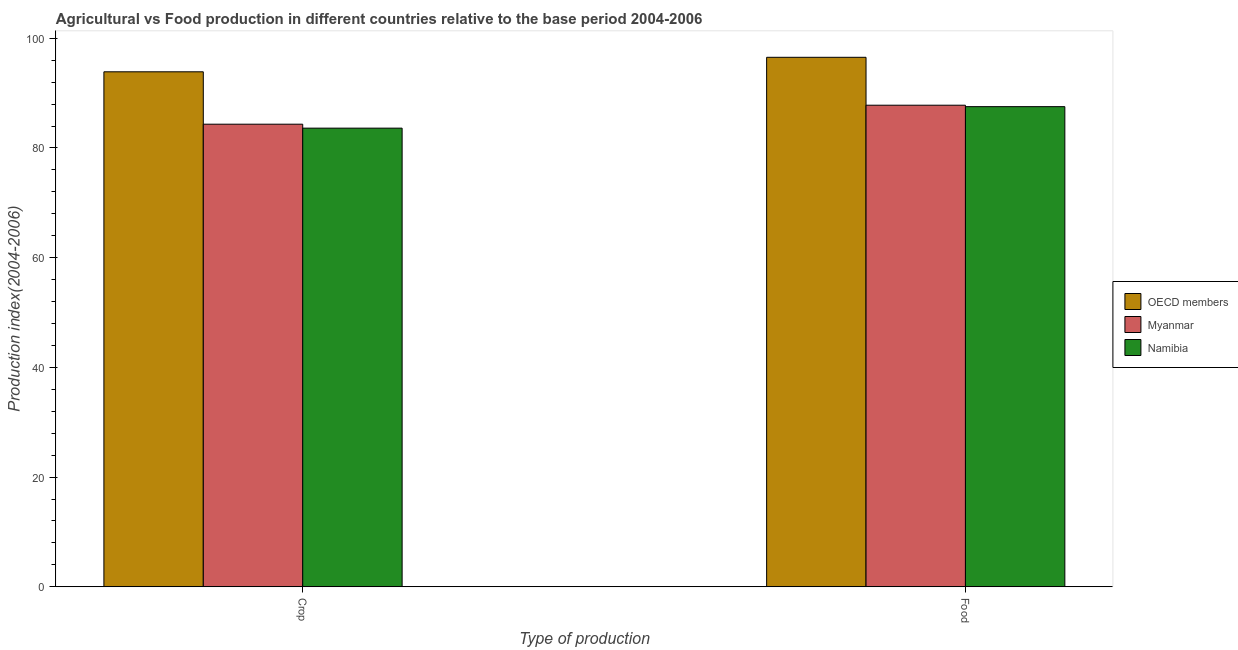How many groups of bars are there?
Offer a terse response. 2. Are the number of bars per tick equal to the number of legend labels?
Give a very brief answer. Yes. What is the label of the 2nd group of bars from the left?
Provide a succinct answer. Food. What is the crop production index in Myanmar?
Give a very brief answer. 84.34. Across all countries, what is the maximum food production index?
Make the answer very short. 96.54. Across all countries, what is the minimum crop production index?
Your answer should be compact. 83.62. In which country was the crop production index minimum?
Give a very brief answer. Namibia. What is the total crop production index in the graph?
Your response must be concise. 261.85. What is the difference between the food production index in Namibia and that in Myanmar?
Your answer should be very brief. -0.26. What is the difference between the food production index in Myanmar and the crop production index in OECD members?
Keep it short and to the point. -6.09. What is the average crop production index per country?
Make the answer very short. 87.28. What is the difference between the food production index and crop production index in OECD members?
Make the answer very short. 2.64. In how many countries, is the crop production index greater than 92 ?
Your response must be concise. 1. What is the ratio of the food production index in Myanmar to that in OECD members?
Keep it short and to the point. 0.91. In how many countries, is the crop production index greater than the average crop production index taken over all countries?
Make the answer very short. 1. What does the 1st bar from the right in Food represents?
Give a very brief answer. Namibia. Where does the legend appear in the graph?
Provide a short and direct response. Center right. How many legend labels are there?
Your answer should be very brief. 3. What is the title of the graph?
Provide a succinct answer. Agricultural vs Food production in different countries relative to the base period 2004-2006. Does "United Kingdom" appear as one of the legend labels in the graph?
Your answer should be compact. No. What is the label or title of the X-axis?
Your answer should be very brief. Type of production. What is the label or title of the Y-axis?
Keep it short and to the point. Production index(2004-2006). What is the Production index(2004-2006) of OECD members in Crop?
Give a very brief answer. 93.89. What is the Production index(2004-2006) of Myanmar in Crop?
Provide a succinct answer. 84.34. What is the Production index(2004-2006) of Namibia in Crop?
Make the answer very short. 83.62. What is the Production index(2004-2006) in OECD members in Food?
Offer a terse response. 96.54. What is the Production index(2004-2006) in Myanmar in Food?
Your answer should be compact. 87.8. What is the Production index(2004-2006) of Namibia in Food?
Provide a short and direct response. 87.54. Across all Type of production, what is the maximum Production index(2004-2006) in OECD members?
Your answer should be compact. 96.54. Across all Type of production, what is the maximum Production index(2004-2006) of Myanmar?
Your answer should be very brief. 87.8. Across all Type of production, what is the maximum Production index(2004-2006) in Namibia?
Your answer should be very brief. 87.54. Across all Type of production, what is the minimum Production index(2004-2006) of OECD members?
Your response must be concise. 93.89. Across all Type of production, what is the minimum Production index(2004-2006) of Myanmar?
Keep it short and to the point. 84.34. Across all Type of production, what is the minimum Production index(2004-2006) of Namibia?
Keep it short and to the point. 83.62. What is the total Production index(2004-2006) of OECD members in the graph?
Provide a short and direct response. 190.43. What is the total Production index(2004-2006) in Myanmar in the graph?
Offer a terse response. 172.14. What is the total Production index(2004-2006) in Namibia in the graph?
Provide a short and direct response. 171.16. What is the difference between the Production index(2004-2006) of OECD members in Crop and that in Food?
Ensure brevity in your answer.  -2.64. What is the difference between the Production index(2004-2006) in Myanmar in Crop and that in Food?
Your answer should be compact. -3.46. What is the difference between the Production index(2004-2006) of Namibia in Crop and that in Food?
Your answer should be compact. -3.92. What is the difference between the Production index(2004-2006) of OECD members in Crop and the Production index(2004-2006) of Myanmar in Food?
Give a very brief answer. 6.09. What is the difference between the Production index(2004-2006) in OECD members in Crop and the Production index(2004-2006) in Namibia in Food?
Your answer should be very brief. 6.35. What is the average Production index(2004-2006) of OECD members per Type of production?
Give a very brief answer. 95.21. What is the average Production index(2004-2006) in Myanmar per Type of production?
Give a very brief answer. 86.07. What is the average Production index(2004-2006) of Namibia per Type of production?
Your response must be concise. 85.58. What is the difference between the Production index(2004-2006) in OECD members and Production index(2004-2006) in Myanmar in Crop?
Your response must be concise. 9.55. What is the difference between the Production index(2004-2006) in OECD members and Production index(2004-2006) in Namibia in Crop?
Your response must be concise. 10.27. What is the difference between the Production index(2004-2006) in Myanmar and Production index(2004-2006) in Namibia in Crop?
Offer a terse response. 0.72. What is the difference between the Production index(2004-2006) in OECD members and Production index(2004-2006) in Myanmar in Food?
Offer a terse response. 8.74. What is the difference between the Production index(2004-2006) in OECD members and Production index(2004-2006) in Namibia in Food?
Your answer should be compact. 9. What is the difference between the Production index(2004-2006) of Myanmar and Production index(2004-2006) of Namibia in Food?
Provide a succinct answer. 0.26. What is the ratio of the Production index(2004-2006) in OECD members in Crop to that in Food?
Keep it short and to the point. 0.97. What is the ratio of the Production index(2004-2006) of Myanmar in Crop to that in Food?
Give a very brief answer. 0.96. What is the ratio of the Production index(2004-2006) of Namibia in Crop to that in Food?
Give a very brief answer. 0.96. What is the difference between the highest and the second highest Production index(2004-2006) of OECD members?
Your answer should be compact. 2.64. What is the difference between the highest and the second highest Production index(2004-2006) in Myanmar?
Provide a short and direct response. 3.46. What is the difference between the highest and the second highest Production index(2004-2006) in Namibia?
Your answer should be compact. 3.92. What is the difference between the highest and the lowest Production index(2004-2006) in OECD members?
Ensure brevity in your answer.  2.64. What is the difference between the highest and the lowest Production index(2004-2006) of Myanmar?
Provide a succinct answer. 3.46. What is the difference between the highest and the lowest Production index(2004-2006) of Namibia?
Provide a short and direct response. 3.92. 